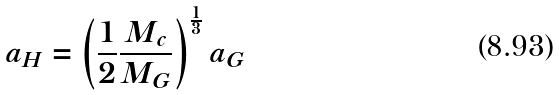<formula> <loc_0><loc_0><loc_500><loc_500>a _ { H } = \left ( \frac { 1 } { 2 } \frac { M _ { c } } { M _ { G } } \right ) ^ { \frac { 1 } { 3 } } a _ { G }</formula> 